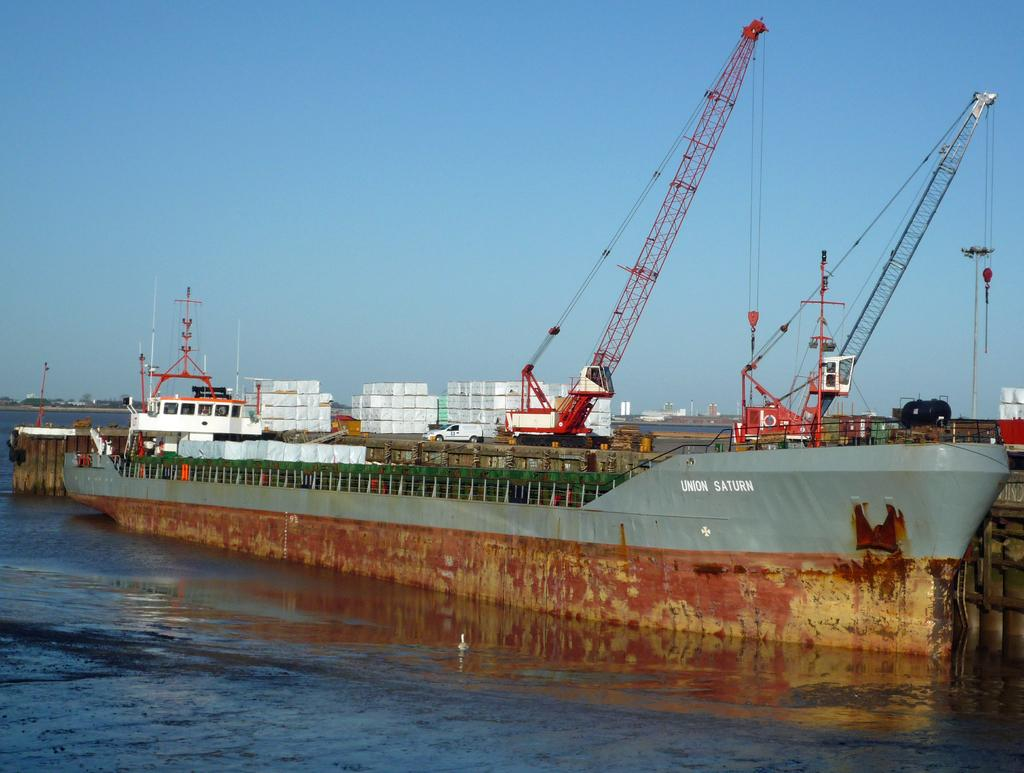What is the main subject of the image? There is a ship in the water. What other types of vehicles can be seen in the image? There are vehicles in the image. What specific type of machinery is present in the image? There are excavators in the image. What can be seen in the background of the image? The sky is visible in the background of the image. What type of light can be seen shining on the ship in the image? There is no specific light source mentioned or visible in the image, so we cannot determine the type of light shining on the ship. 